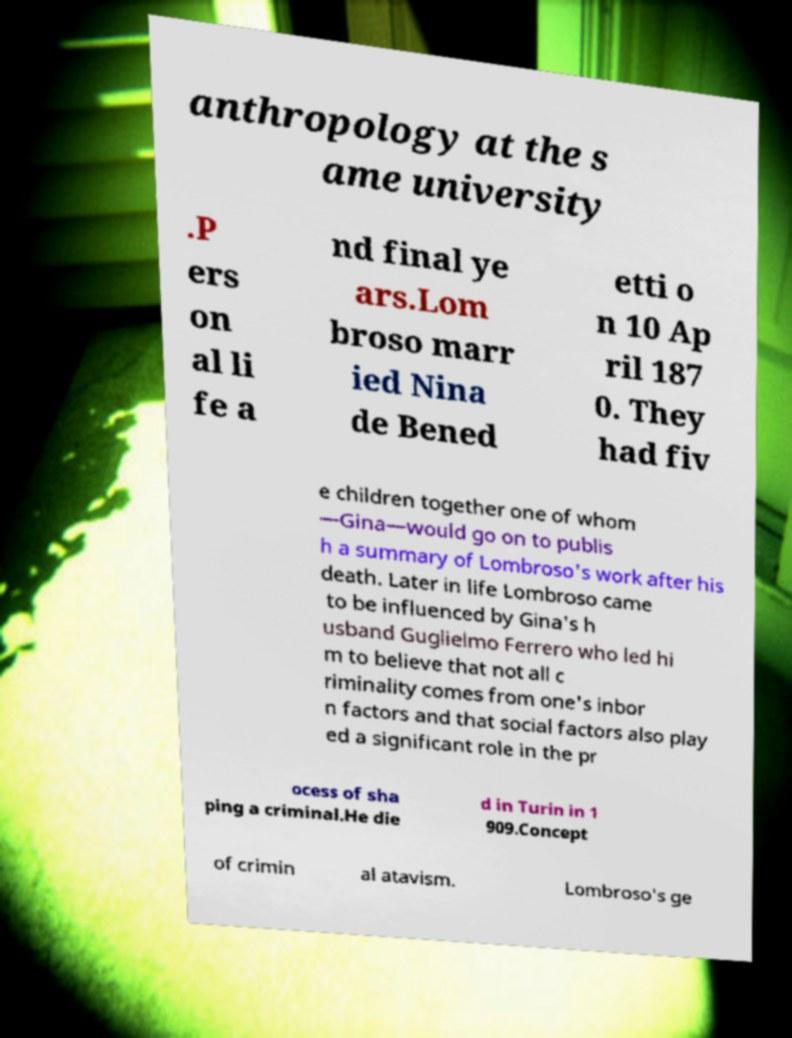Could you assist in decoding the text presented in this image and type it out clearly? anthropology at the s ame university .P ers on al li fe a nd final ye ars.Lom broso marr ied Nina de Bened etti o n 10 Ap ril 187 0. They had fiv e children together one of whom —Gina—would go on to publis h a summary of Lombroso's work after his death. Later in life Lombroso came to be influenced by Gina's h usband Guglielmo Ferrero who led hi m to believe that not all c riminality comes from one's inbor n factors and that social factors also play ed a significant role in the pr ocess of sha ping a criminal.He die d in Turin in 1 909.Concept of crimin al atavism. Lombroso's ge 